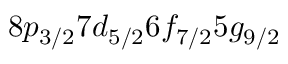Convert formula to latex. <formula><loc_0><loc_0><loc_500><loc_500>8 p _ { 3 / 2 } 7 d _ { 5 / 2 } 6 f _ { 7 / 2 } 5 g _ { 9 / 2 }</formula> 